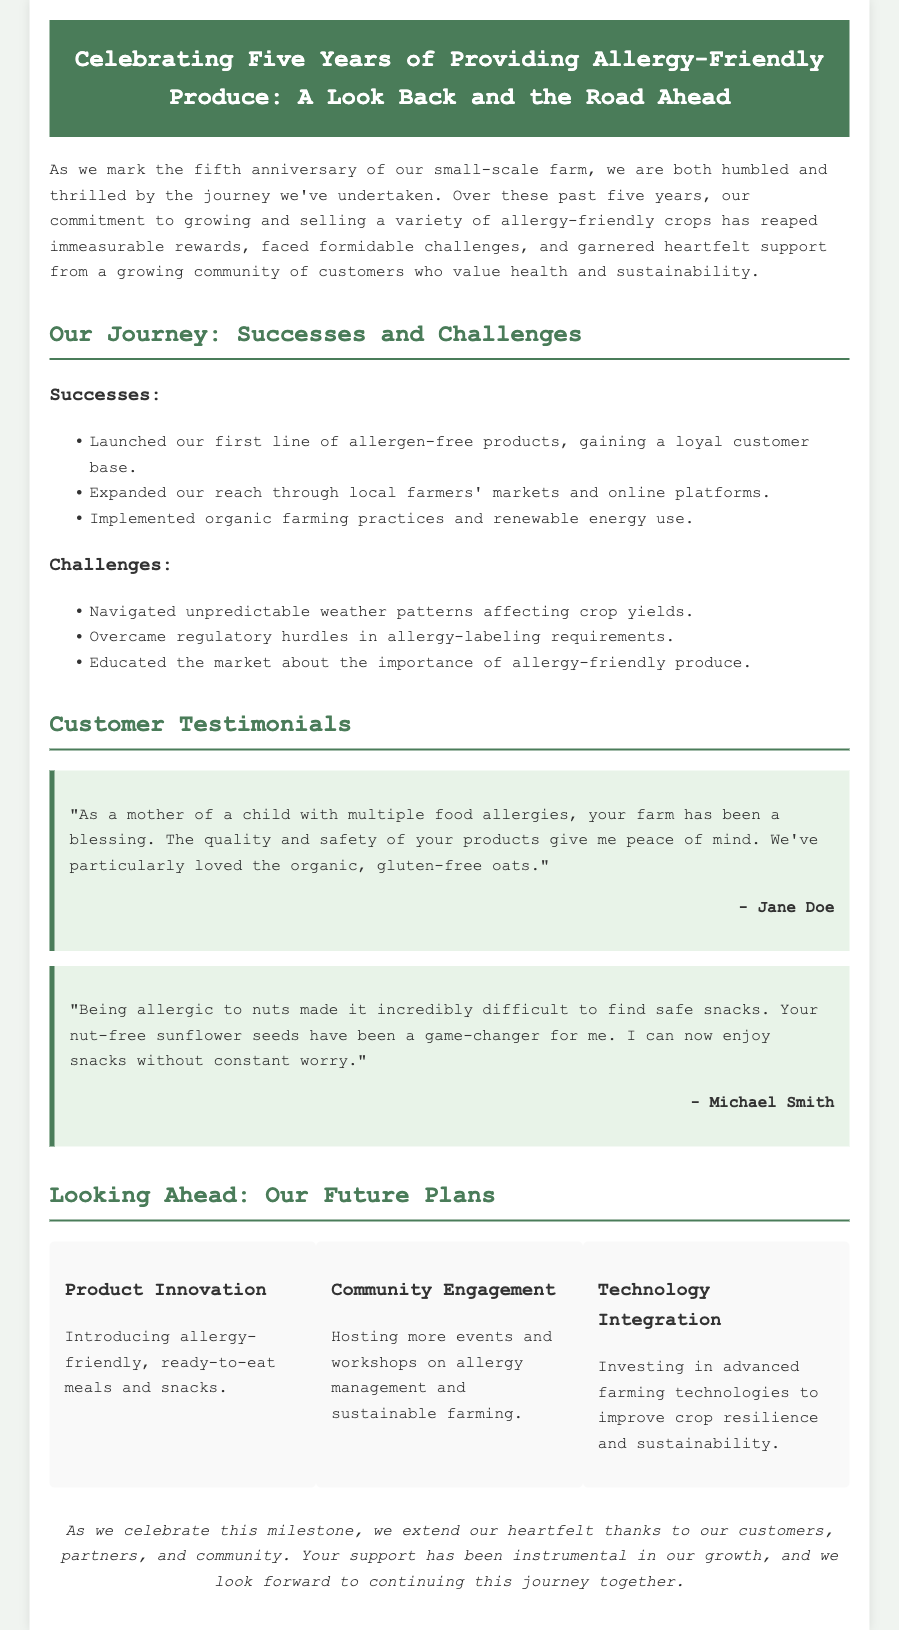What is the primary focus of the farm? The document states the primary focus is on growing and selling a variety of allergy-friendly crops.
Answer: Allergy-friendly crops What is one key success mentioned in the document? The farm launched its first line of allergen-free products, which helped gain a loyal customer base.
Answer: Launched first line of allergen-free products How many years has the farm been operating? The document celebrates the fifth anniversary of the farm's operation.
Answer: Five years Who is a customer that provided a testimonial? One customer who provided a testimonial is Jane Doe.
Answer: Jane Doe What challenge related to climate does the farm face? The farm faces challenges from unpredictable weather patterns affecting crop yields.
Answer: Unpredictable weather patterns What type of future plan involves community interaction? The farm plans to host more events and workshops on allergy management and sustainable farming as part of community engagement.
Answer: Community engagement What product innovation is the farm planning? The farm plans to introduce allergy-friendly, ready-to-eat meals and snacks.
Answer: Allergy-friendly, ready-to-eat meals and snacks What style is used for the testimonials? The testimonials are styled with a background color of light green and a border on the left.
Answer: Background color of light green What is a farmer's primary source of growth according to the document? The document attributes the farm's growth to the support of customers, partners, and the community.
Answer: Support from customers, partners, and community 